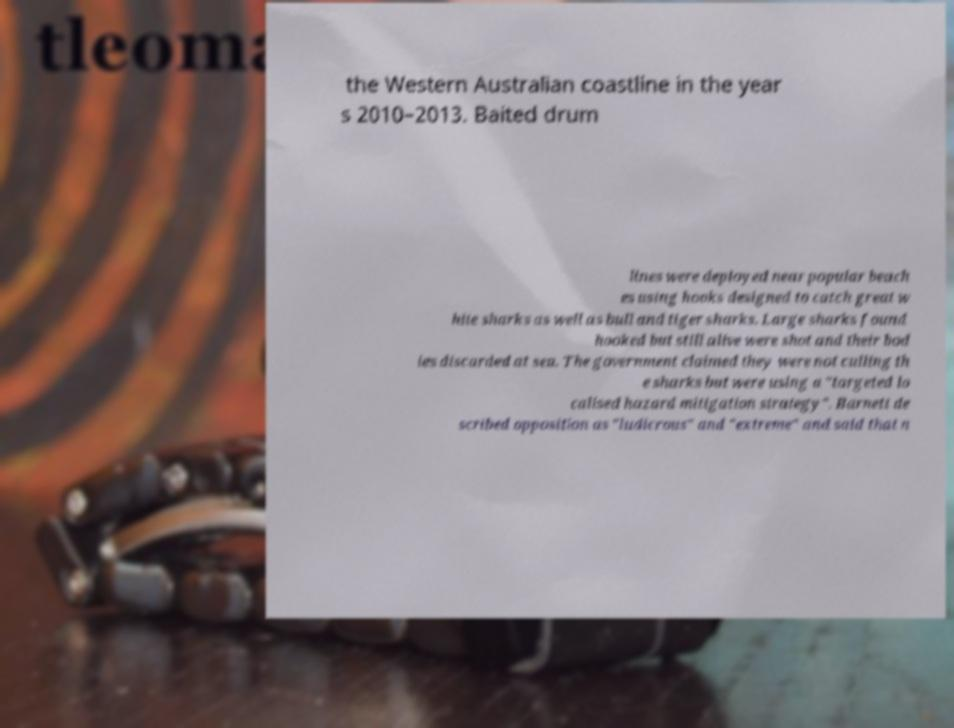There's text embedded in this image that I need extracted. Can you transcribe it verbatim? the Western Australian coastline in the year s 2010–2013. Baited drum lines were deployed near popular beach es using hooks designed to catch great w hite sharks as well as bull and tiger sharks. Large sharks found hooked but still alive were shot and their bod ies discarded at sea. The government claimed they were not culling th e sharks but were using a "targeted lo calised hazard mitigation strategy". Barnett de scribed opposition as "ludicrous" and "extreme" and said that n 